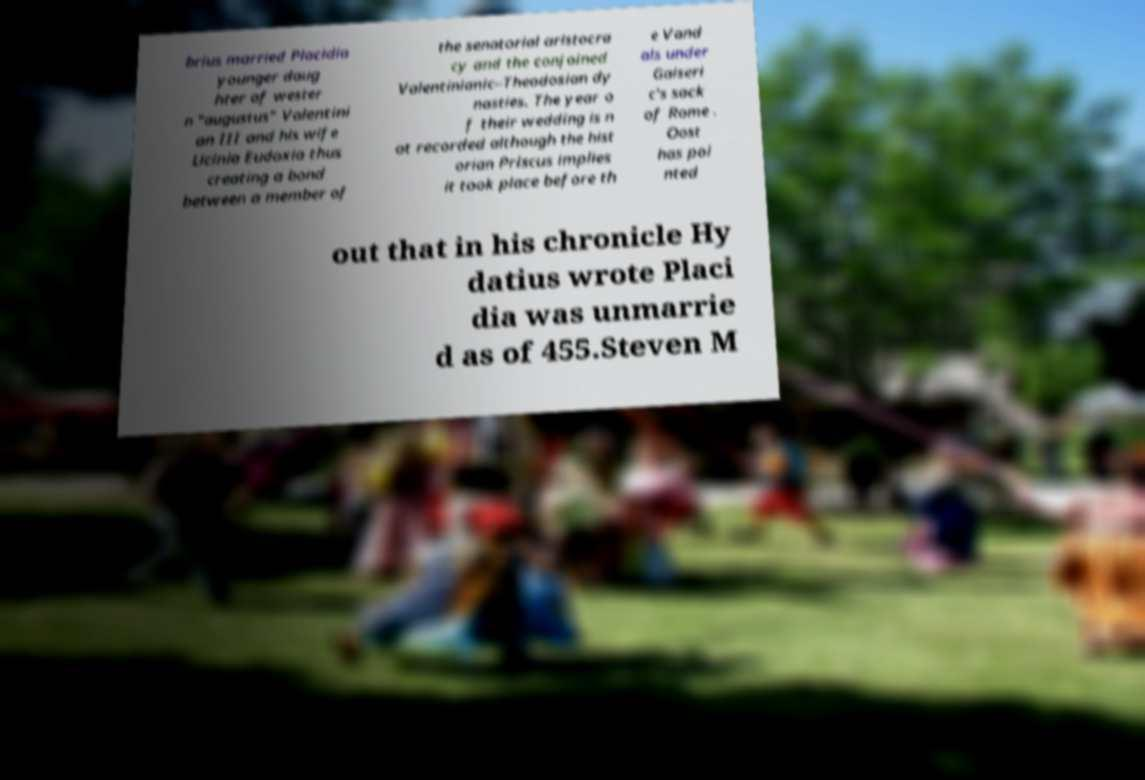Can you accurately transcribe the text from the provided image for me? brius married Placidia younger daug hter of wester n "augustus" Valentini an III and his wife Licinia Eudoxia thus creating a bond between a member of the senatorial aristocra cy and the conjoined Valentinianic–Theodosian dy nasties. The year o f their wedding is n ot recorded although the hist orian Priscus implies it took place before th e Vand als under Gaiseri c's sack of Rome . Oost has poi nted out that in his chronicle Hy datius wrote Placi dia was unmarrie d as of 455.Steven M 